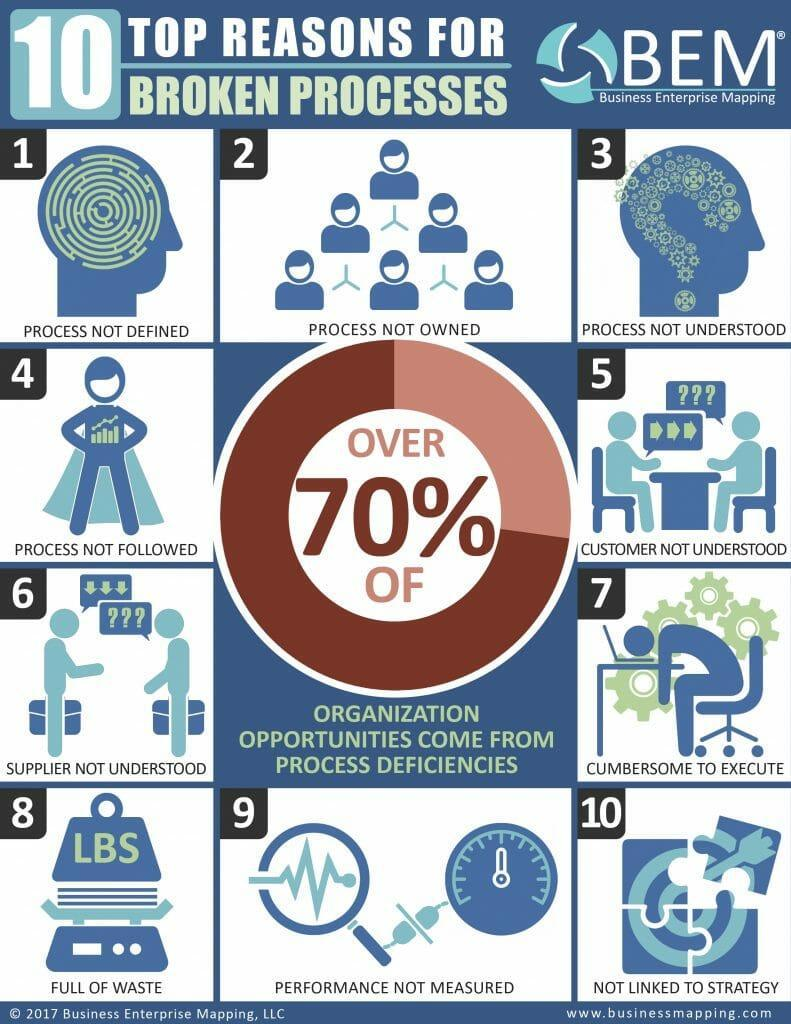How many processes are broken due to lack of understanding ?
Answer the question with a short phrase. 3 Which broken process shows the image of an inverted question mark? Process not understood 